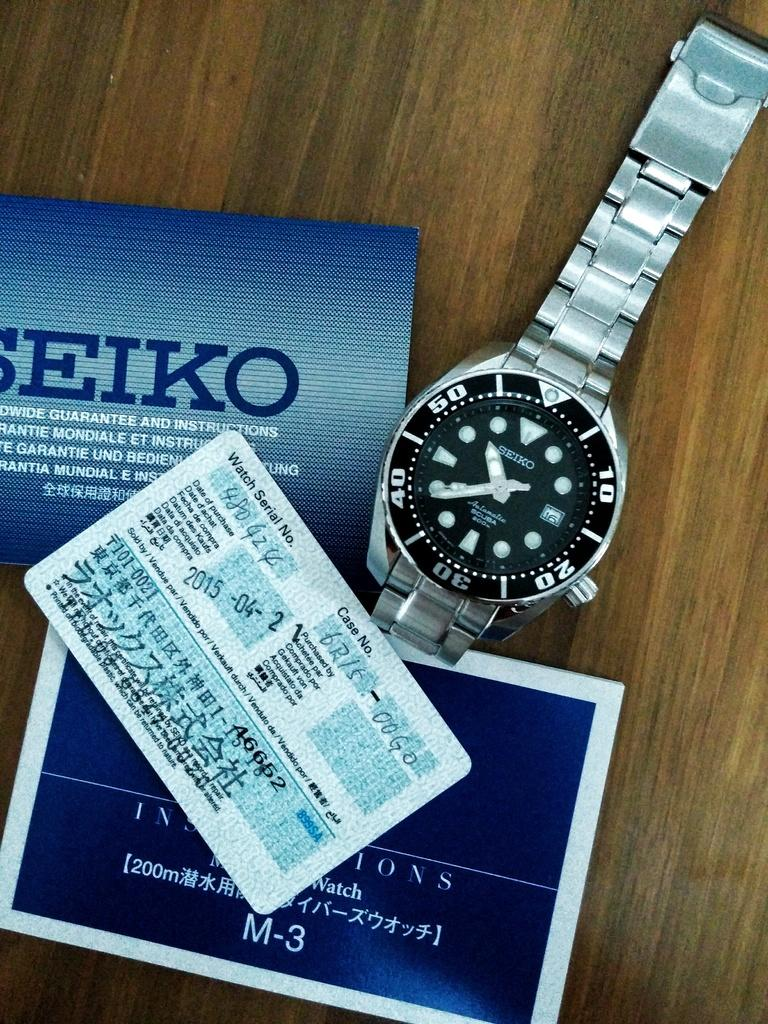<image>
Describe the image concisely. A Seiko watch sits with some booklets and a certificate. 